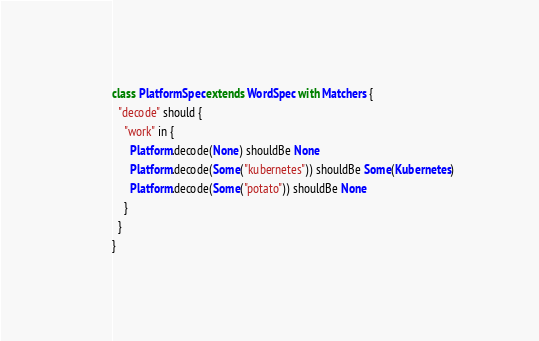<code> <loc_0><loc_0><loc_500><loc_500><_Scala_>class PlatformSpec extends WordSpec with Matchers {
  "decode" should {
    "work" in {
      Platform.decode(None) shouldBe None
      Platform.decode(Some("kubernetes")) shouldBe Some(Kubernetes)
      Platform.decode(Some("potato")) shouldBe None
    }
  }
}
</code> 